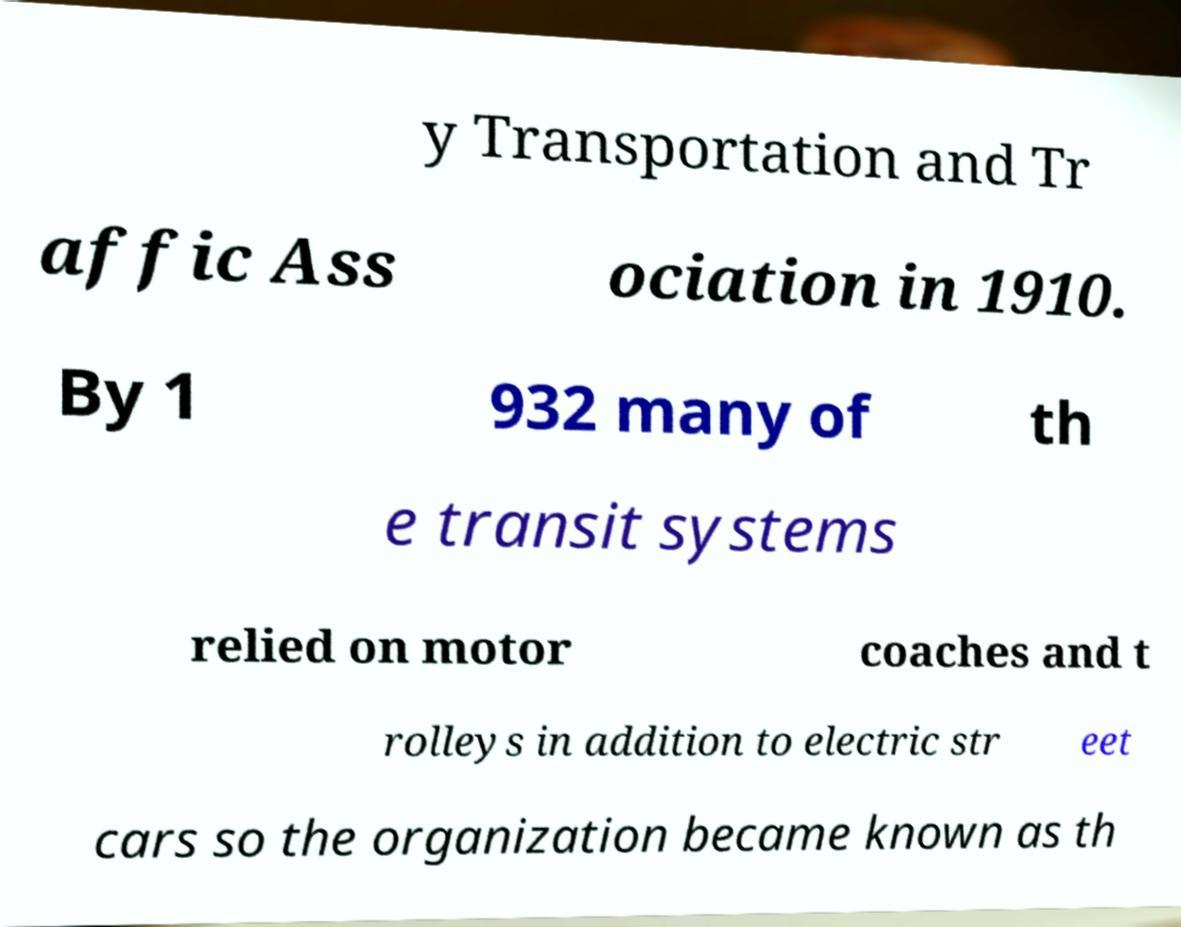What messages or text are displayed in this image? I need them in a readable, typed format. y Transportation and Tr affic Ass ociation in 1910. By 1 932 many of th e transit systems relied on motor coaches and t rolleys in addition to electric str eet cars so the organization became known as th 